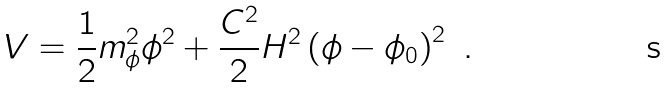<formula> <loc_0><loc_0><loc_500><loc_500>V = \frac { 1 } { 2 } m _ { \phi } ^ { 2 } \phi ^ { 2 } + \frac { C ^ { 2 } } { 2 } H ^ { 2 } \left ( \phi - \phi _ { 0 } \right ) ^ { 2 } \ .</formula> 